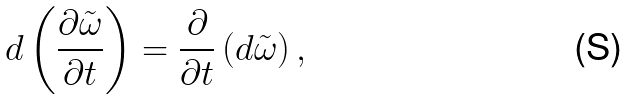Convert formula to latex. <formula><loc_0><loc_0><loc_500><loc_500>d \left ( \frac { \partial \tilde { \omega } } { \partial t } \right ) = \frac { \partial } { \partial t } \left ( d \tilde { \omega } \right ) ,</formula> 